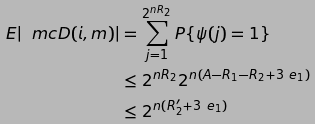Convert formula to latex. <formula><loc_0><loc_0><loc_500><loc_500>E | \ m c { D } ( i , m ) | & = \sum _ { j = 1 } ^ { 2 ^ { n R _ { 2 } } } P \{ \psi ( j ) = 1 \} \\ & \leq 2 ^ { n R _ { 2 } } 2 ^ { n ( A - R _ { 1 } - R _ { 2 } + 3 \ e _ { 1 } ) } \\ & \leq 2 ^ { n ( R ^ { \prime } _ { 2 } + 3 \ e _ { 1 } ) }</formula> 